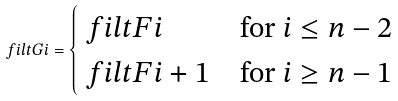<formula> <loc_0><loc_0><loc_500><loc_500>\ f i l t G i = \begin{cases} \ f i l t F { i } & \text {for $i\leq n-2$} \\ \ f i l t F { i + 1 } & \text {for $i\geq n-1$} \end{cases}</formula> 